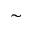Convert formula to latex. <formula><loc_0><loc_0><loc_500><loc_500>\sim</formula> 